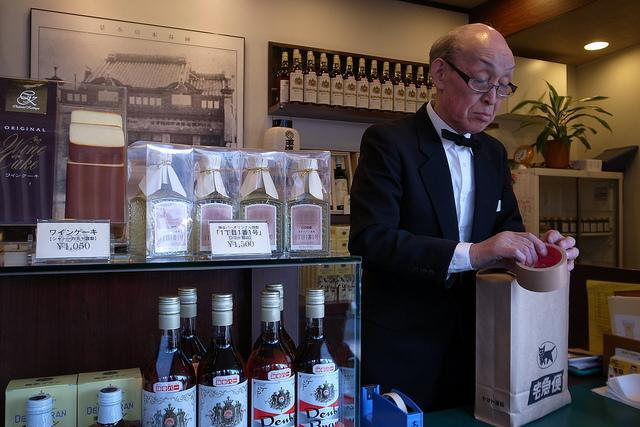What sort of beverages are sold here? alcoholic 